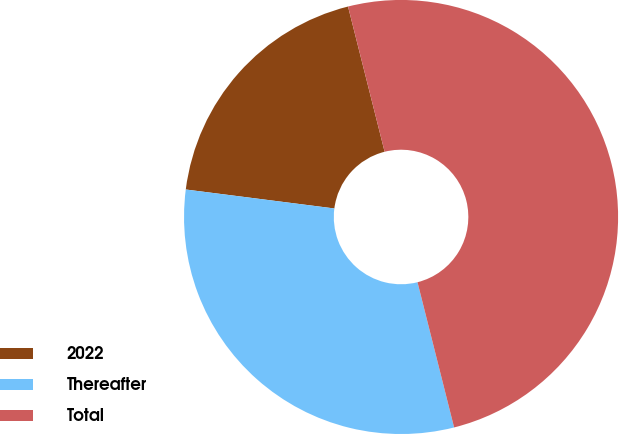Convert chart. <chart><loc_0><loc_0><loc_500><loc_500><pie_chart><fcel>2022<fcel>Thereafter<fcel>Total<nl><fcel>19.05%<fcel>30.95%<fcel>50.0%<nl></chart> 